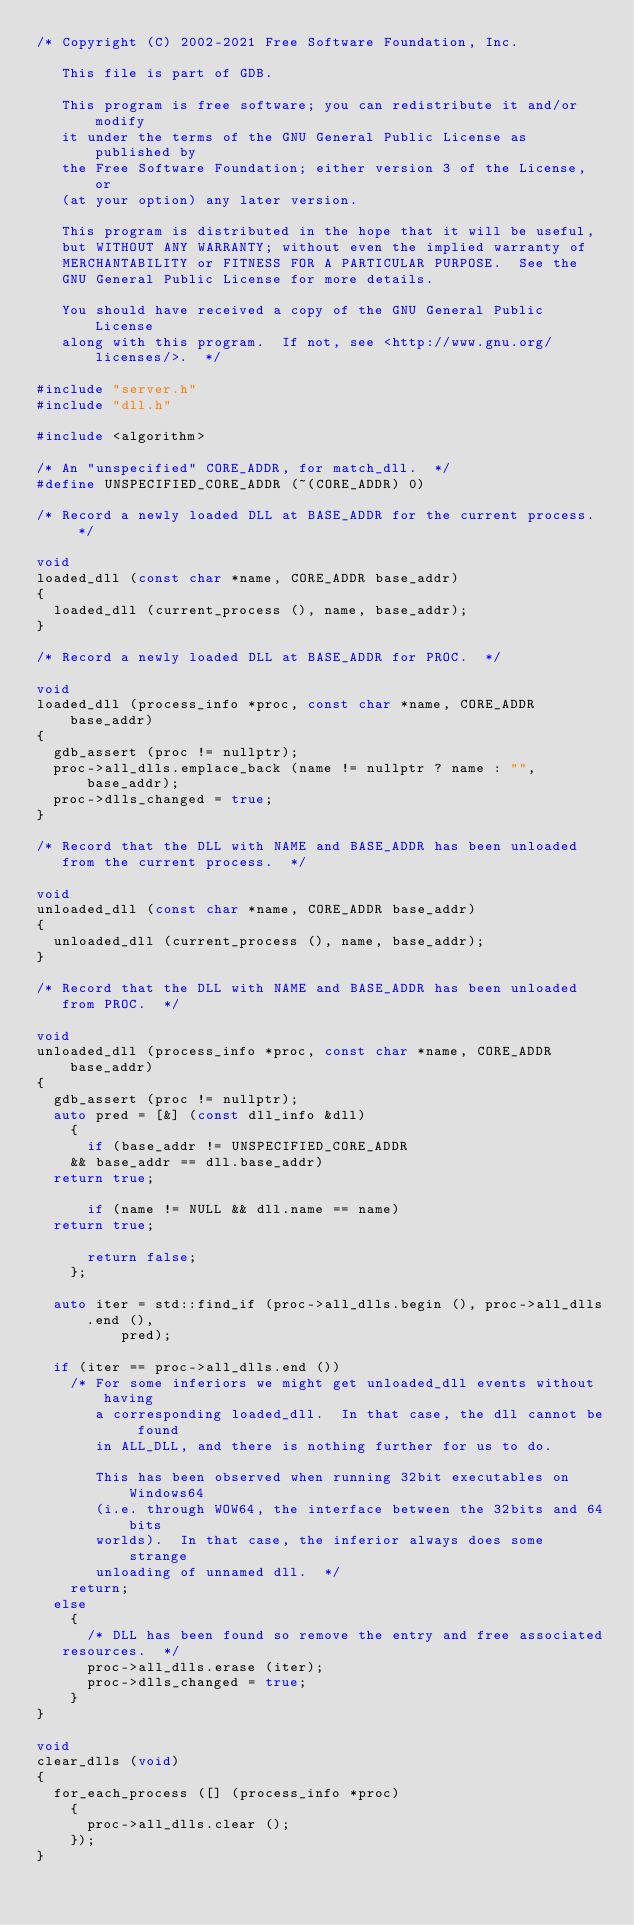Convert code to text. <code><loc_0><loc_0><loc_500><loc_500><_C++_>/* Copyright (C) 2002-2021 Free Software Foundation, Inc.

   This file is part of GDB.

   This program is free software; you can redistribute it and/or modify
   it under the terms of the GNU General Public License as published by
   the Free Software Foundation; either version 3 of the License, or
   (at your option) any later version.

   This program is distributed in the hope that it will be useful,
   but WITHOUT ANY WARRANTY; without even the implied warranty of
   MERCHANTABILITY or FITNESS FOR A PARTICULAR PURPOSE.  See the
   GNU General Public License for more details.

   You should have received a copy of the GNU General Public License
   along with this program.  If not, see <http://www.gnu.org/licenses/>.  */

#include "server.h"
#include "dll.h"

#include <algorithm>

/* An "unspecified" CORE_ADDR, for match_dll.  */
#define UNSPECIFIED_CORE_ADDR (~(CORE_ADDR) 0)

/* Record a newly loaded DLL at BASE_ADDR for the current process.  */

void
loaded_dll (const char *name, CORE_ADDR base_addr)
{
  loaded_dll (current_process (), name, base_addr);
}

/* Record a newly loaded DLL at BASE_ADDR for PROC.  */

void
loaded_dll (process_info *proc, const char *name, CORE_ADDR base_addr)
{
  gdb_assert (proc != nullptr);
  proc->all_dlls.emplace_back (name != nullptr ? name : "", base_addr);
  proc->dlls_changed = true;
}

/* Record that the DLL with NAME and BASE_ADDR has been unloaded
   from the current process.  */

void
unloaded_dll (const char *name, CORE_ADDR base_addr)
{
  unloaded_dll (current_process (), name, base_addr);
}

/* Record that the DLL with NAME and BASE_ADDR has been unloaded
   from PROC.  */

void
unloaded_dll (process_info *proc, const char *name, CORE_ADDR base_addr)
{
  gdb_assert (proc != nullptr);
  auto pred = [&] (const dll_info &dll)
    {
      if (base_addr != UNSPECIFIED_CORE_ADDR
	  && base_addr == dll.base_addr)
	return true;

      if (name != NULL && dll.name == name)
	return true;

      return false;
    };

  auto iter = std::find_if (proc->all_dlls.begin (), proc->all_dlls.end (),
			    pred);

  if (iter == proc->all_dlls.end ())
    /* For some inferiors we might get unloaded_dll events without having
       a corresponding loaded_dll.  In that case, the dll cannot be found
       in ALL_DLL, and there is nothing further for us to do.

       This has been observed when running 32bit executables on Windows64
       (i.e. through WOW64, the interface between the 32bits and 64bits
       worlds).  In that case, the inferior always does some strange
       unloading of unnamed dll.  */
    return;
  else
    {
      /* DLL has been found so remove the entry and free associated
	 resources.  */
      proc->all_dlls.erase (iter);
      proc->dlls_changed = true;
    }
}

void
clear_dlls (void)
{
  for_each_process ([] (process_info *proc)
    {
      proc->all_dlls.clear ();
    });
}
</code> 